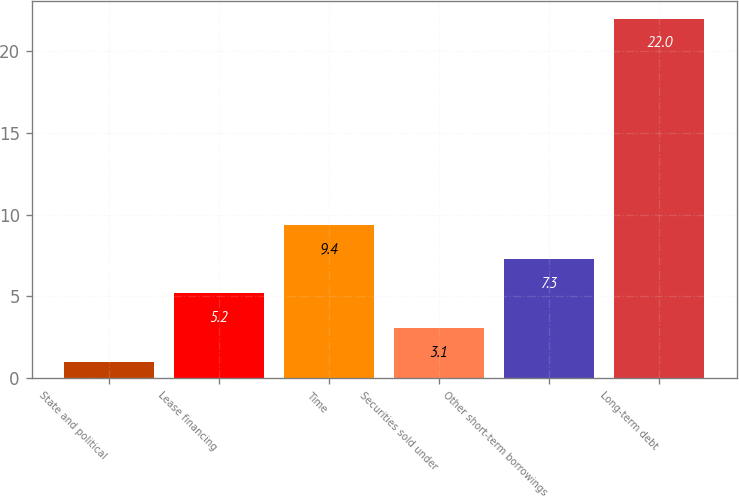Convert chart. <chart><loc_0><loc_0><loc_500><loc_500><bar_chart><fcel>State and political<fcel>Lease financing<fcel>Time<fcel>Securities sold under<fcel>Other short-term borrowings<fcel>Long-term debt<nl><fcel>1<fcel>5.2<fcel>9.4<fcel>3.1<fcel>7.3<fcel>22<nl></chart> 